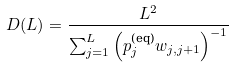<formula> <loc_0><loc_0><loc_500><loc_500>D ( L ) = \frac { L ^ { 2 } } { \sum _ { j = 1 } ^ { L } \left ( p _ { j } ^ { \text {(eq)} } w _ { j , j + 1 } \right ) ^ { - 1 } }</formula> 